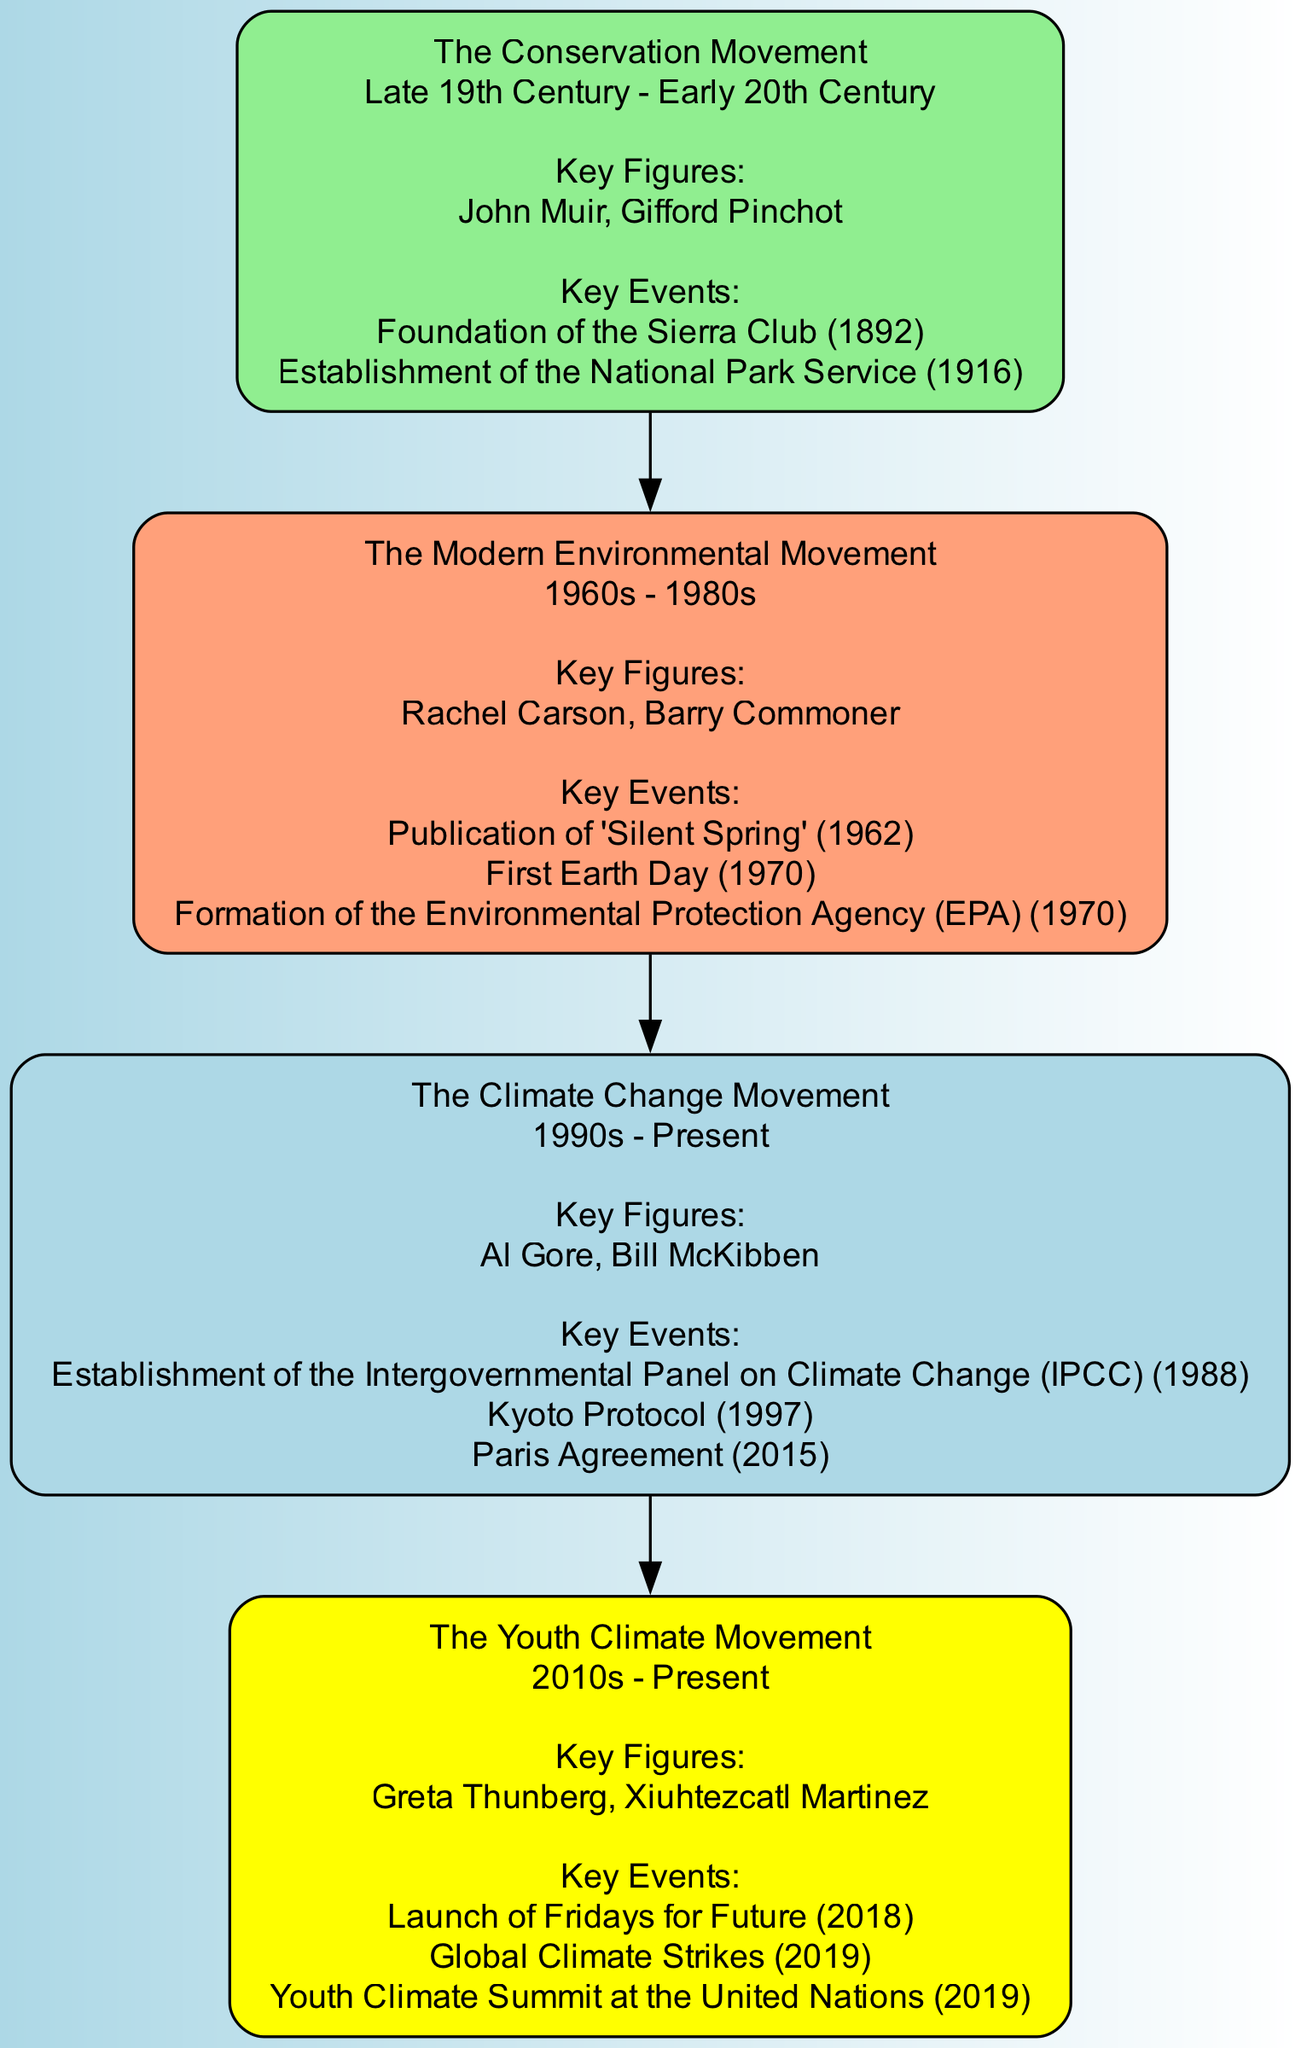What are the key figures of The Modern Environmental Movement? The diagram lists the key figures for The Modern Environmental Movement as Rachel Carson and Barry Commoner. I locate "The Modern Environmental Movement" node and read the "Key Figures" section.
Answer: Rachel Carson, Barry Commoner Which movement directly precedes The Youth Climate Movement? By examining the diagram's lineage, I see that The Climate Change Movement has a direct edge leading to The Youth Climate Movement, indicating it precedes it.
Answer: The Climate Change Movement What year did the first Earth Day take place? I find the key event "First Earth Day (1970)" listed under The Modern Environmental Movement. I extract the year from the event description.
Answer: 1970 How many key events are listed for The Climate Change Movement? I count the number of key events listed under The Climate Change Movement, which are three: the establishment of the IPCC, Kyoto Protocol, and Paris Agreement. This requires checking the corresponding events section.
Answer: 3 Which environmental movement has the key event "Foundation of the Sierra Club"? I identify the movement associated with the event "Foundation of the Sierra Club (1892)" and find it is linked to The Conservation Movement, as it is listed under its key events.
Answer: The Conservation Movement What color represents The Youth Climate Movement in the diagram? I check the node for The Youth Climate Movement, which is colored yellow as indicated by the color code in the edges of the diagram.
Answer: Yellow Name a key figure of The Conservation Movement. From the diagram, I locate The Conservation Movement node and see that one of its key figures listed is John Muir.
Answer: John Muir Which environmental movement began in the late 19th century? Reviewing the timeline shown in the nodes, I find that The Conservation Movement is described as being from the late 19th century to early 20th century.
Answer: The Conservation Movement What is the relationship between The Modern Environmental Movement and the establishment of the EPA? I observe that the event "Formation of the Environmental Protection Agency (EPA) (1970)" is a key event listed under The Modern Environmental Movement, indicating a direct relationship where it is a milestone event of that movement.
Answer: Key event 